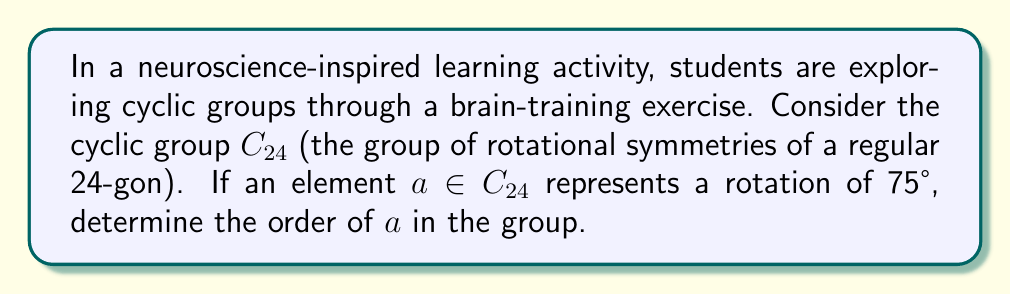Can you solve this math problem? Let's approach this step-by-step, using concepts that align with neuroscience-based learning:

1) First, recall that in a cyclic group $C_n$, an element $a$ represents a rotation of $\frac{360°}{n}$ multiplied by some integer $k$.

2) In this case, $n = 24$, so each "step" in the group represents a rotation of $\frac{360°}{24} = 15°$.

3) The given rotation is 75°. We need to find how many 15° rotations this is equivalent to:

   $\frac{75°}{15°} = 5$

4) This means $a$ is equivalent to 5 steps in $C_{24}$, or in group theory notation: $a = g^5$ where $g$ is the generator of $C_{24}$.

5) To find the order of $a$, we need to determine the smallest positive integer $m$ such that $a^m = e$ (the identity element).

6) In cyclic group terms, we're looking for how many times we need to apply the 75° rotation to get back to the starting position (360° or 0°).

7) We can express this mathematically:

   $75° \cdot m \equiv 0° \pmod{360°}$

8) Solving this congruence:
   
   $75m \equiv 0 \pmod{360}$
   $3m \equiv 0 \pmod{24}$

9) The smallest positive $m$ that satisfies this is $m = 8$.

10) We can verify: $75° \cdot 8 = 600° = 360° + 240° \equiv 240° \equiv 0° \pmod{360°}$

Therefore, the order of $a$ in $C_{24}$ is 8.
Answer: The order of the element $a$ in $C_{24}$ is 8. 